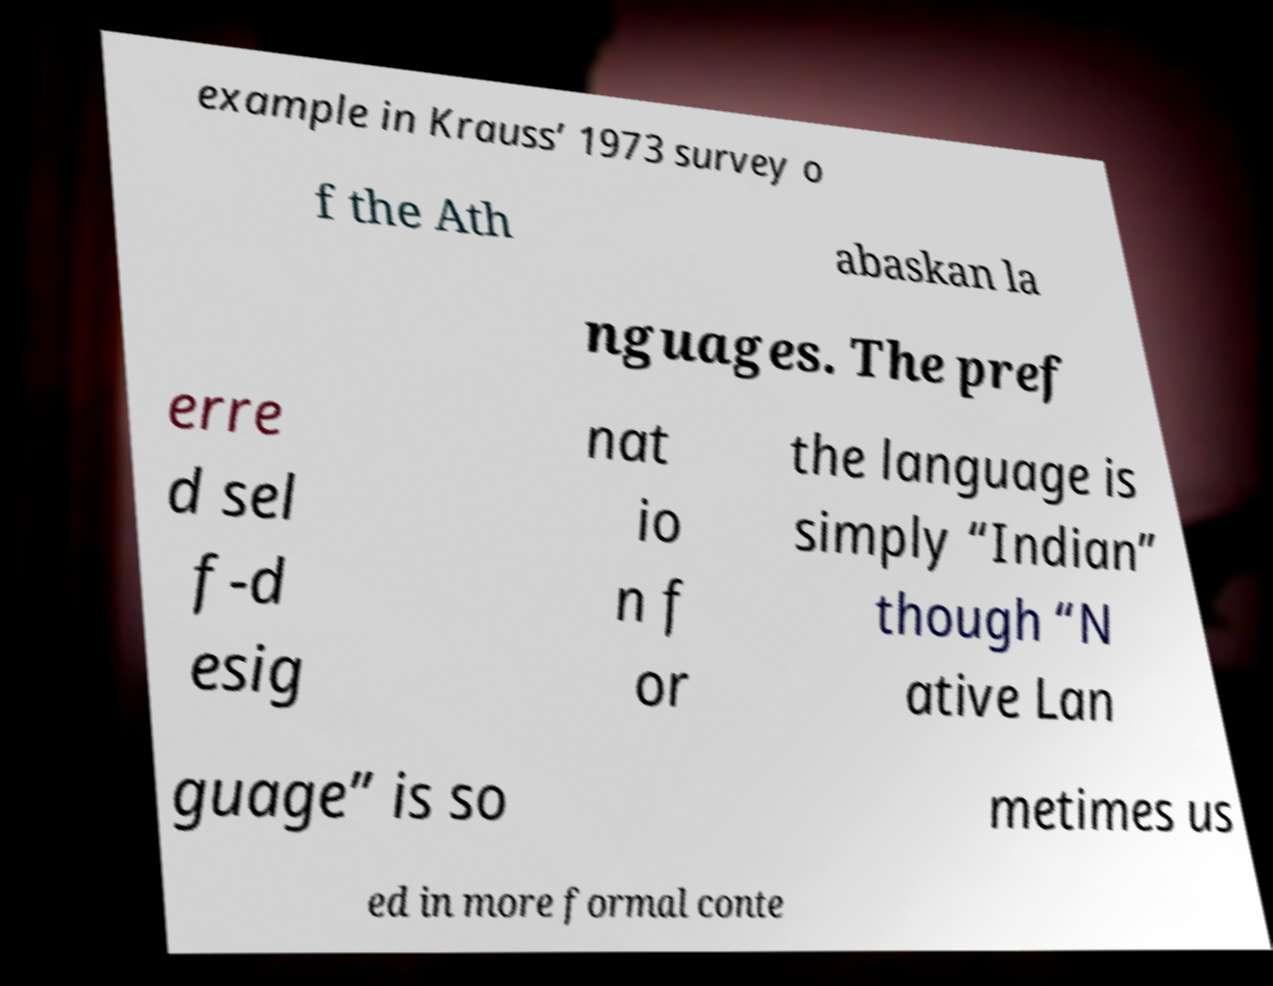Can you read and provide the text displayed in the image?This photo seems to have some interesting text. Can you extract and type it out for me? example in Krauss’ 1973 survey o f the Ath abaskan la nguages. The pref erre d sel f-d esig nat io n f or the language is simply “Indian” though “N ative Lan guage” is so metimes us ed in more formal conte 